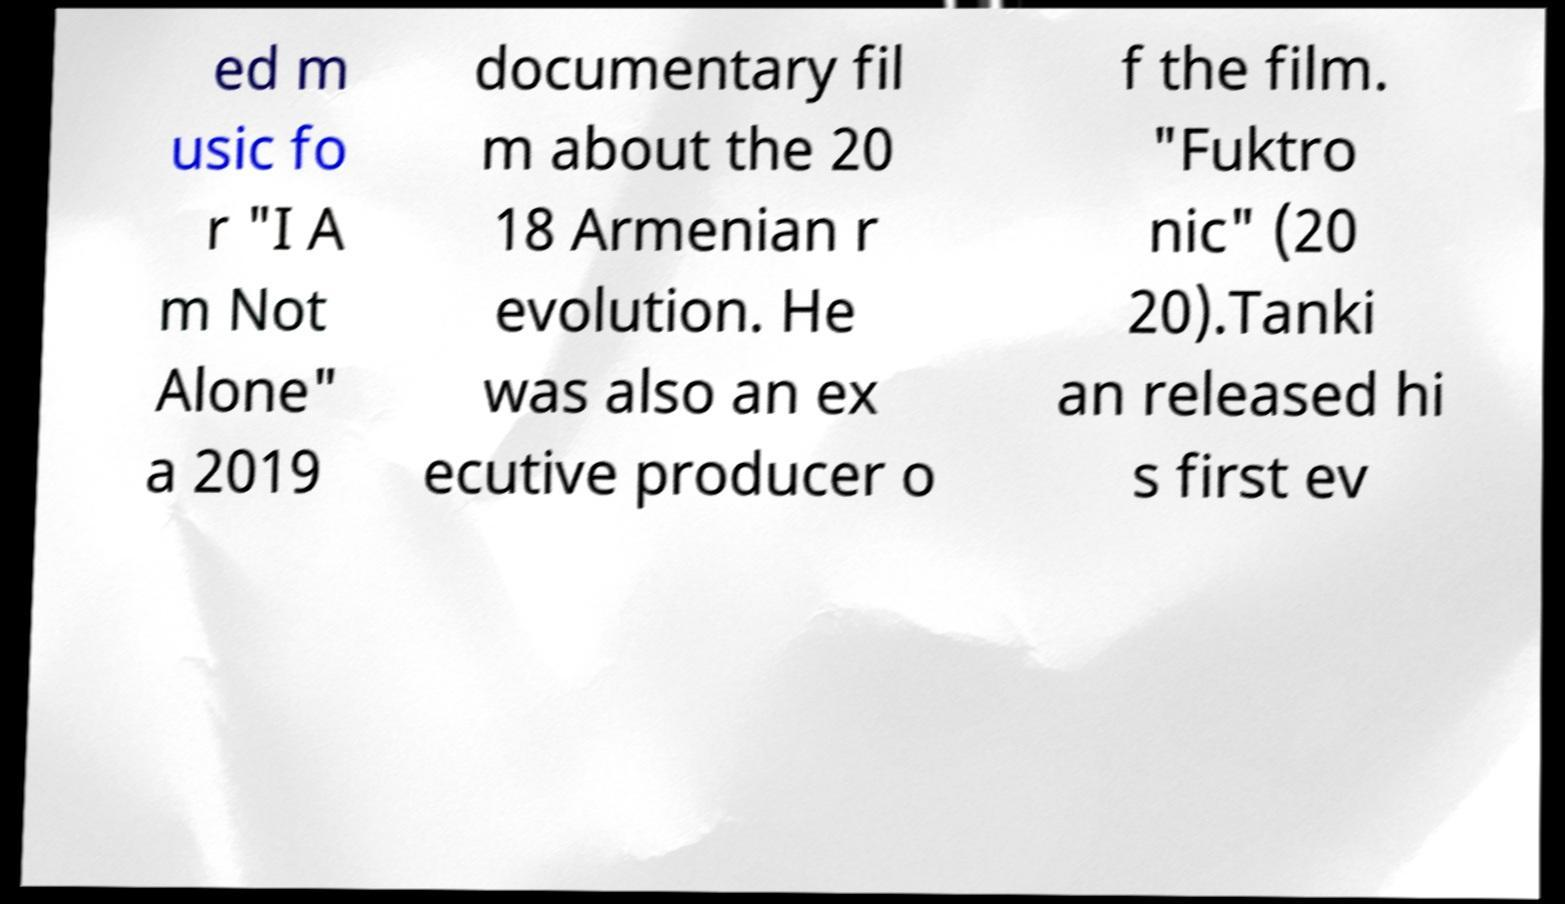There's text embedded in this image that I need extracted. Can you transcribe it verbatim? ed m usic fo r "I A m Not Alone" a 2019 documentary fil m about the 20 18 Armenian r evolution. He was also an ex ecutive producer o f the film. "Fuktro nic" (20 20).Tanki an released hi s first ev 